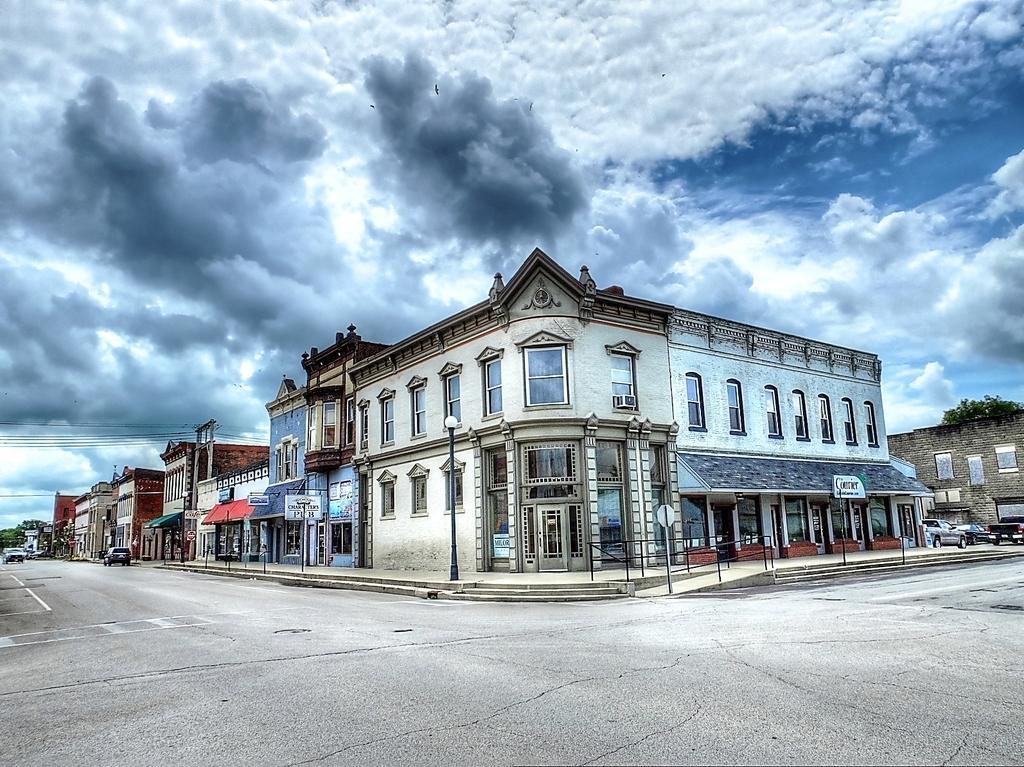Could you give a brief overview of what you see in this image? Here we can see buildings, poles, boards, vehicles, and trees. There is a road. In the background there is sky with clouds. 